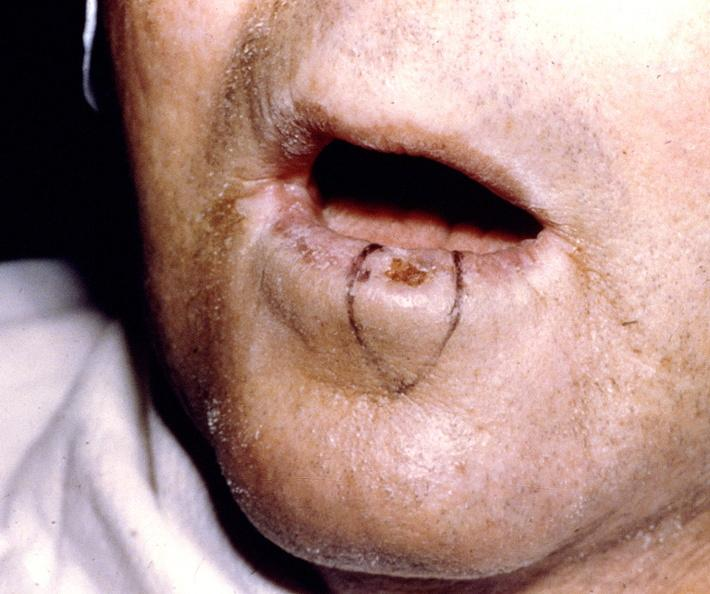does this image show squamous cell carcinoma, lip?
Answer the question using a single word or phrase. Yes 